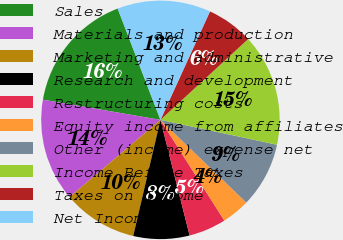Convert chart. <chart><loc_0><loc_0><loc_500><loc_500><pie_chart><fcel>Sales<fcel>Materials and production<fcel>Marketing and administrative<fcel>Research and development<fcel>Restructuring costs<fcel>Equity income from affiliates<fcel>Other (income) expense net<fcel>Income Before Taxes<fcel>Taxes on Income<fcel>Net Income<nl><fcel>16.45%<fcel>13.92%<fcel>10.13%<fcel>7.6%<fcel>5.06%<fcel>3.8%<fcel>8.86%<fcel>15.19%<fcel>6.33%<fcel>12.66%<nl></chart> 